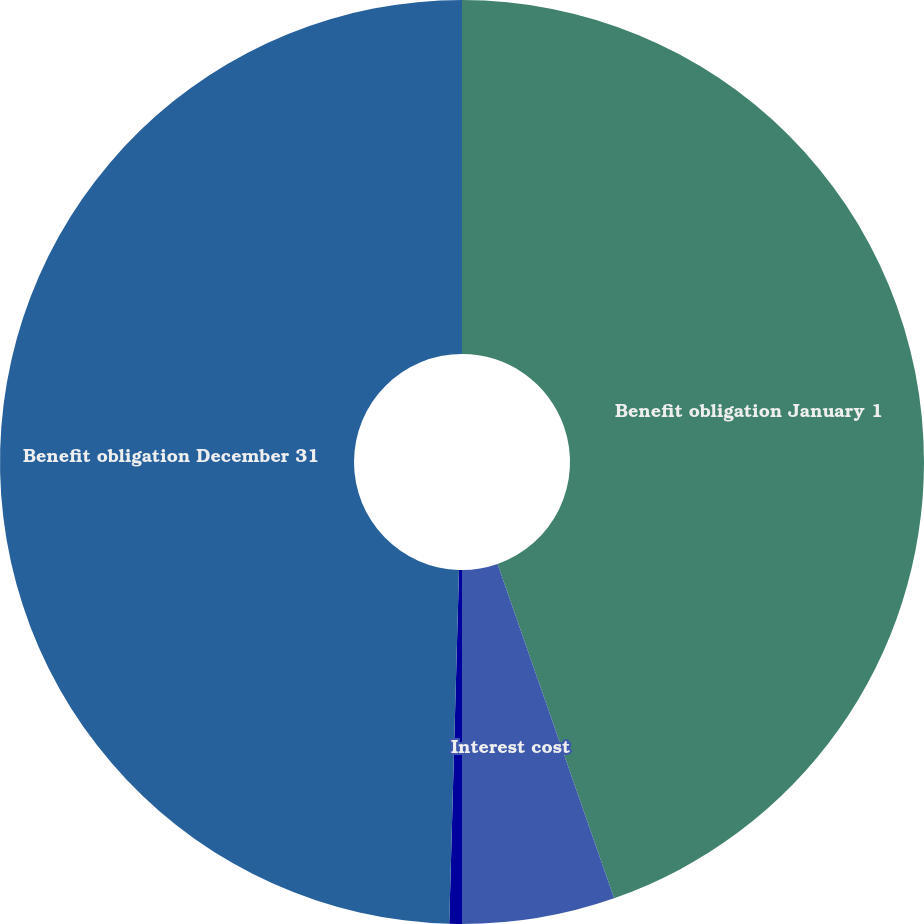Convert chart to OTSL. <chart><loc_0><loc_0><loc_500><loc_500><pie_chart><fcel>Benefit obligation January 1<fcel>Interest cost<fcel>Benefits paid<fcel>Benefit obligation December 31<nl><fcel>44.66%<fcel>5.34%<fcel>0.44%<fcel>49.56%<nl></chart> 